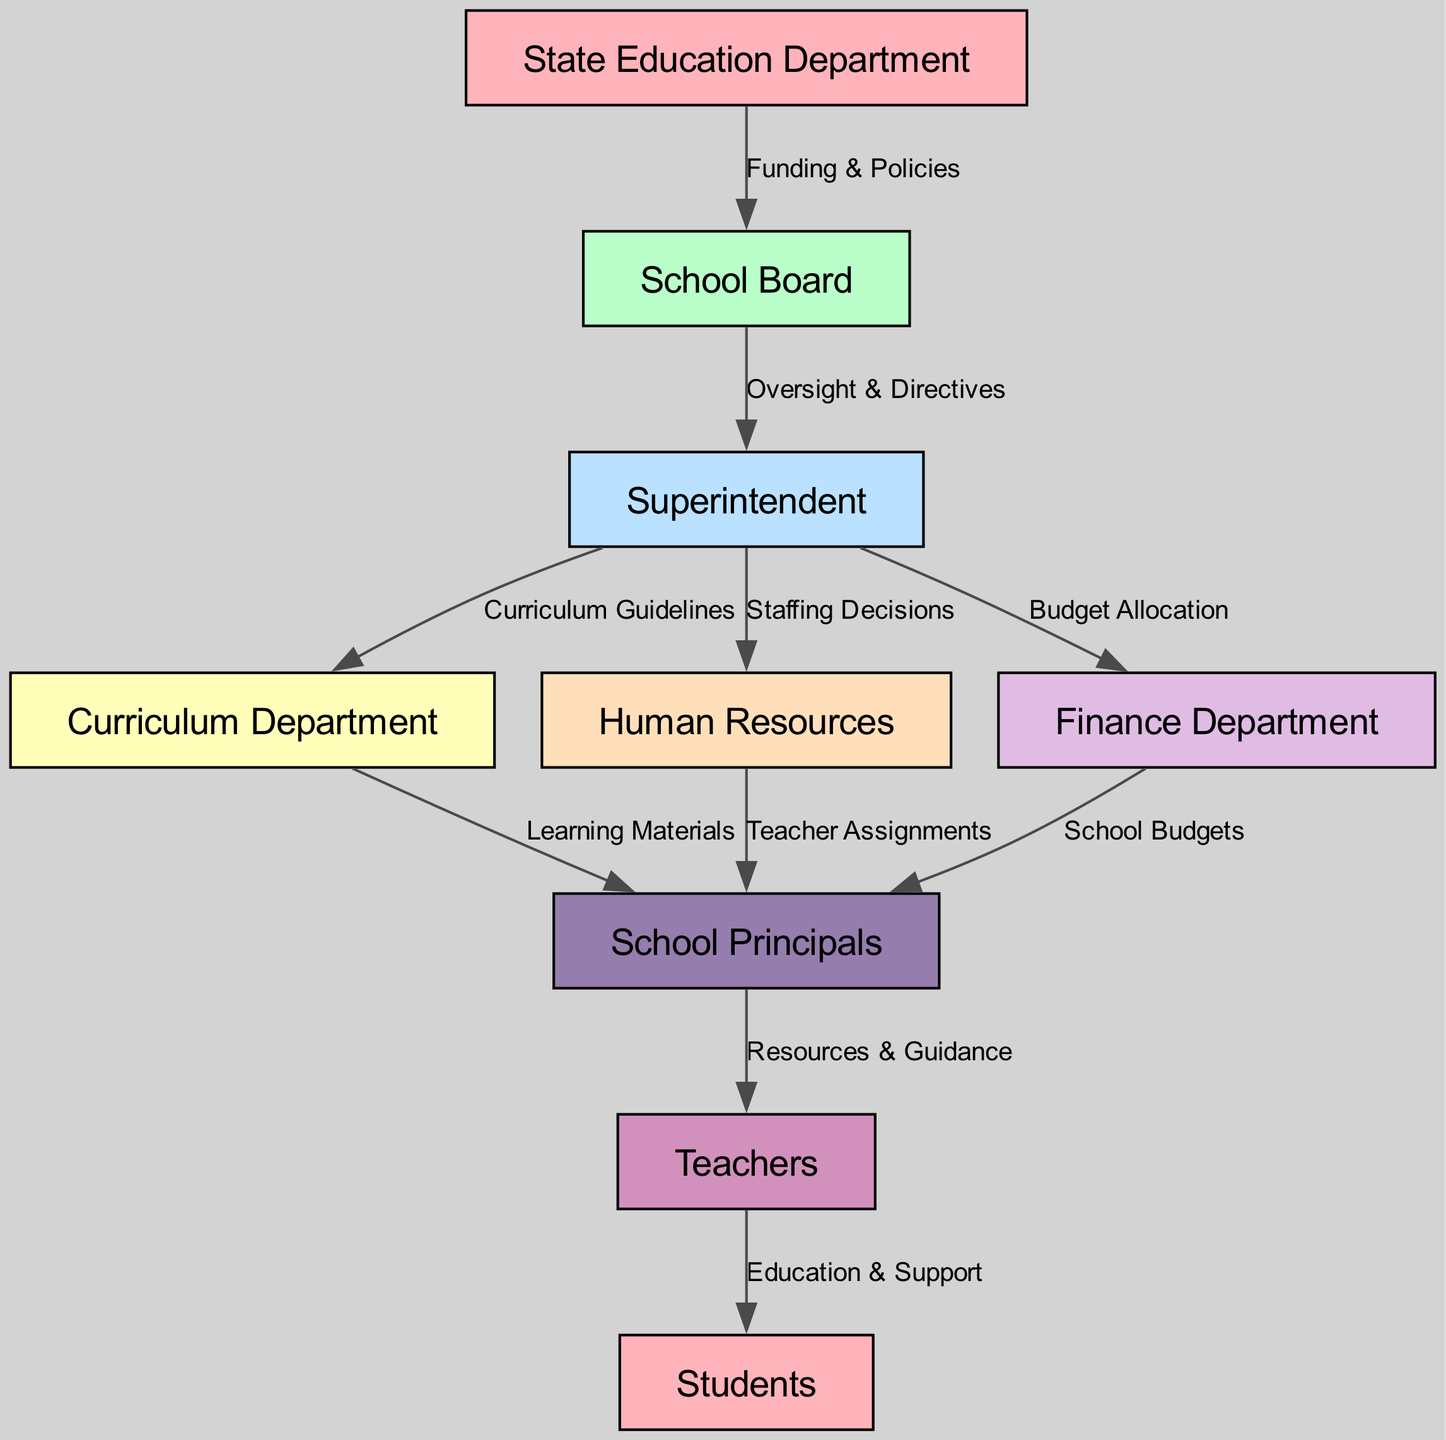What is the total number of nodes in the diagram? The diagram contains nine distinct nodes representing different entities in the school district. After counting each node listed, the result is nine.
Answer: 9 What does the State Education Department provide to the School Board? The diagram indicates that the State Education Department is responsible for providing Funding & Policies to the School Board, as shown by the edge connecting these two nodes with that label.
Answer: Funding & Policies Who receives resources from the School Principals? According to the diagram, School Principals provide Resources & Guidance to Teachers, which is a direct outcome of their role and the direction of the edge connecting them.
Answer: Teachers From which department do School Principals receive curriculum guidelines? The arrow connecting the Superintendent to the Curriculum Department conveys that it is the Superintendent who provides Curriculum Guidelines to School Principals, showing the flow of information in that direction.
Answer: Superintendent What type of decisions does the Superintendent make regarding Human Resources? The diagram includes an edge between the Superintendent and Human Resources that is labeled as Staffing Decisions, indicating this specific decision-making responsibility of the Superintendent.
Answer: Staffing Decisions How many edges are there in total? By counting the connections (edges) displayed in the diagram, it can be noted that there are ten total connections among the specified nodes, representing the flow of resources and decision-making processes.
Answer: 10 Which node is directly connected to the Finance Department? The diagram shows that the Finance Department has a direct connection to the School Principals, indicated by the edge labeled School Budgets, thus illustrating that the School Principals receive budget-related information from the Finance Department.
Answer: School Principals What is the common outcome that flows from Teachers to Students? The direct connection from Teachers to Students in the diagram is labeled Education & Support, indicating the primary result of their interaction and guidance within the educational system.
Answer: Education & Support Who oversees the Superintendent? The School Board is identified in the diagram as the entity that oversees the Superintendent, as evidenced by the edge labeled Oversight & Directives connecting these nodes.
Answer: School Board 